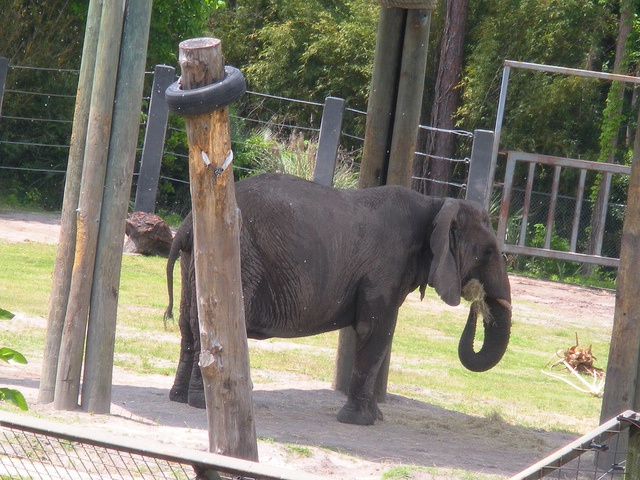Describe the objects in this image and their specific colors. I can see a elephant in darkgreen, gray, black, and khaki tones in this image. 